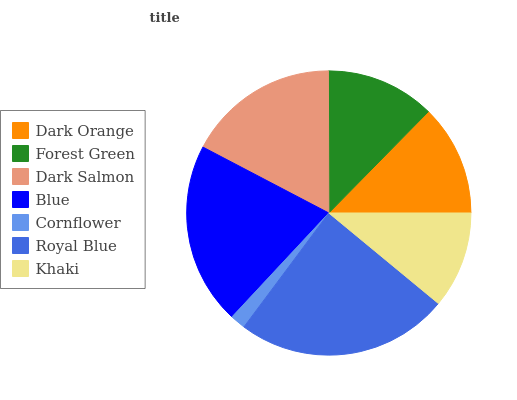Is Cornflower the minimum?
Answer yes or no. Yes. Is Royal Blue the maximum?
Answer yes or no. Yes. Is Forest Green the minimum?
Answer yes or no. No. Is Forest Green the maximum?
Answer yes or no. No. Is Dark Orange greater than Forest Green?
Answer yes or no. Yes. Is Forest Green less than Dark Orange?
Answer yes or no. Yes. Is Forest Green greater than Dark Orange?
Answer yes or no. No. Is Dark Orange less than Forest Green?
Answer yes or no. No. Is Dark Orange the high median?
Answer yes or no. Yes. Is Dark Orange the low median?
Answer yes or no. Yes. Is Cornflower the high median?
Answer yes or no. No. Is Dark Salmon the low median?
Answer yes or no. No. 